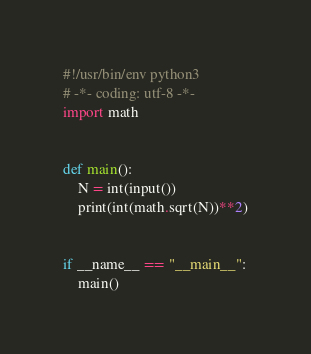Convert code to text. <code><loc_0><loc_0><loc_500><loc_500><_Python_>#!/usr/bin/env python3
# -*- coding: utf-8 -*-
import math


def main():
    N = int(input())
    print(int(math.sqrt(N))**2)


if __name__ == "__main__":
    main()
</code> 